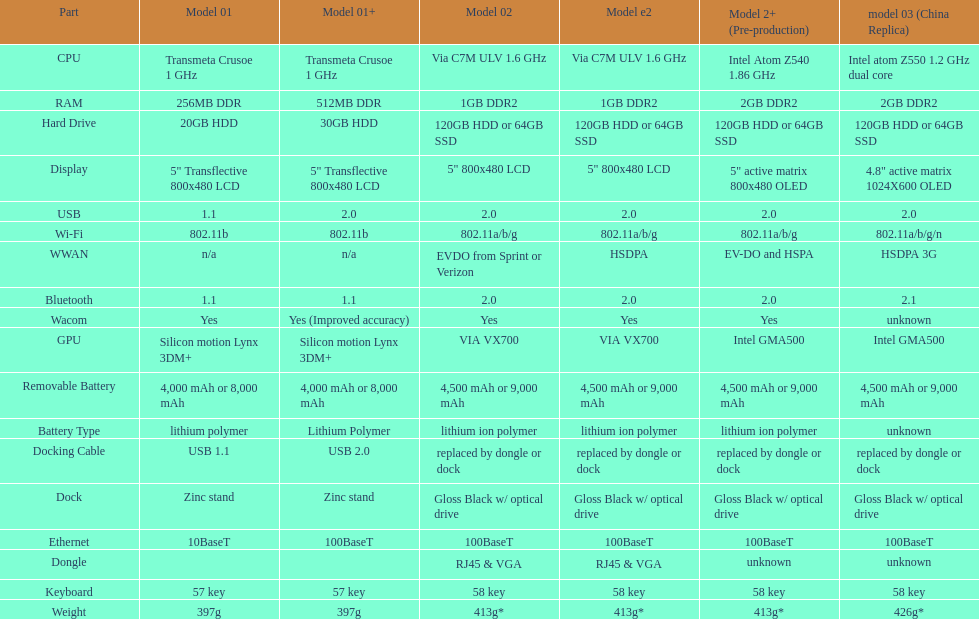How much more weight does the model 3 have over model 1? 29g. 